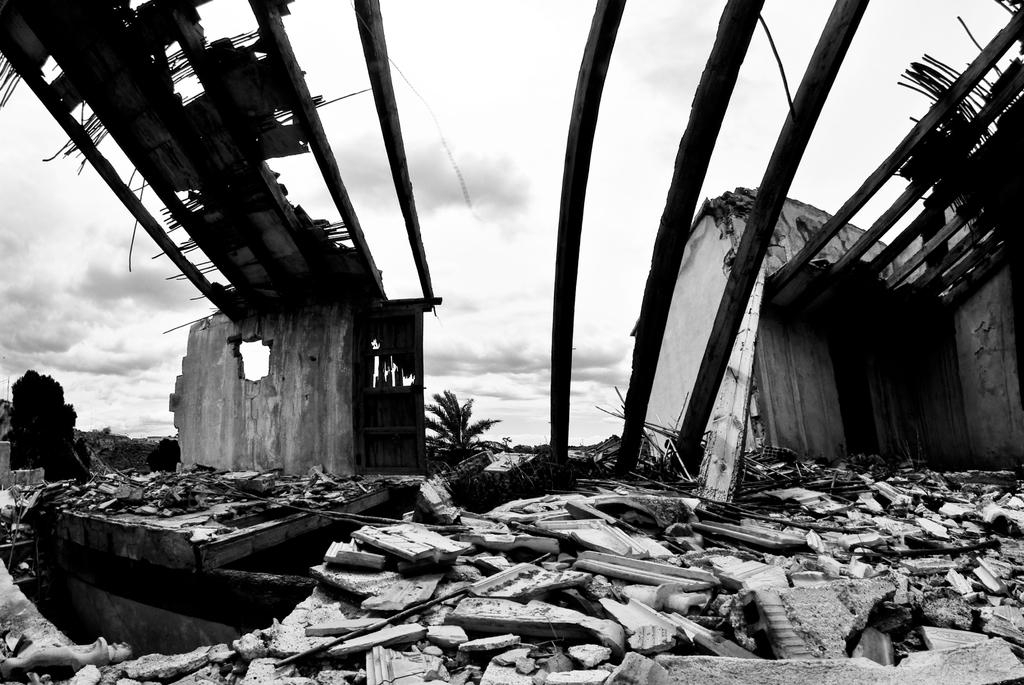What is the color scheme of the image? The image is black and white. What is the main subject in the image? There is a collapsed building in the image. What can be seen in the background of the image? The sky is visible in the background of the image. Where is the loaf of bread located in the image? There is no loaf of bread present in the image. What type of cushion can be seen supporting the collapsed building in the image? There is no cushion present in the image, and the collapsed building is not supported by any cushion. 